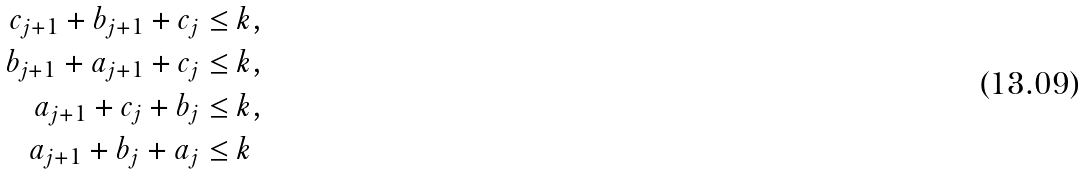Convert formula to latex. <formula><loc_0><loc_0><loc_500><loc_500>c _ { j + 1 } + b _ { j + 1 } + c _ { j } & \leq k , \\ b _ { j + 1 } + a _ { j + 1 } + c _ { j } & \leq k , \\ a _ { j + 1 } + c _ { j } + b _ { j } & \leq k , \\ a _ { j + 1 } + b _ { j } + a _ { j } & \leq k</formula> 